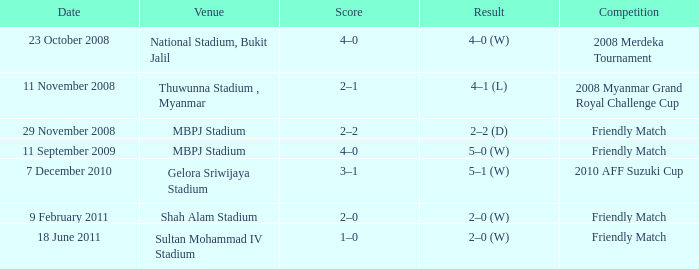What is the Result of the Competition at MBPJ Stadium with a Score of 4–0? 5–0 (W). Parse the full table. {'header': ['Date', 'Venue', 'Score', 'Result', 'Competition'], 'rows': [['23 October 2008', 'National Stadium, Bukit Jalil', '4–0', '4–0 (W)', '2008 Merdeka Tournament'], ['11 November 2008', 'Thuwunna Stadium , Myanmar', '2–1', '4–1 (L)', '2008 Myanmar Grand Royal Challenge Cup'], ['29 November 2008', 'MBPJ Stadium', '2–2', '2–2 (D)', 'Friendly Match'], ['11 September 2009', 'MBPJ Stadium', '4–0', '5–0 (W)', 'Friendly Match'], ['7 December 2010', 'Gelora Sriwijaya Stadium', '3–1', '5–1 (W)', '2010 AFF Suzuki Cup'], ['9 February 2011', 'Shah Alam Stadium', '2–0', '2–0 (W)', 'Friendly Match'], ['18 June 2011', 'Sultan Mohammad IV Stadium', '1–0', '2–0 (W)', 'Friendly Match']]} 